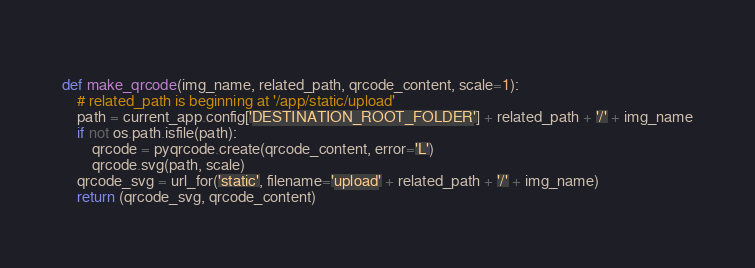Convert code to text. <code><loc_0><loc_0><loc_500><loc_500><_Python_>    
def make_qrcode(img_name, related_path, qrcode_content, scale=1):
    # related_path is beginning at '/app/static/upload'
    path = current_app.config['DESTINATION_ROOT_FOLDER'] + related_path + '/' + img_name
    if not os.path.isfile(path):
        qrcode = pyqrcode.create(qrcode_content, error='L')
        qrcode.svg(path, scale)
    qrcode_svg = url_for('static', filename='upload' + related_path + '/' + img_name)
    return (qrcode_svg, qrcode_content)</code> 